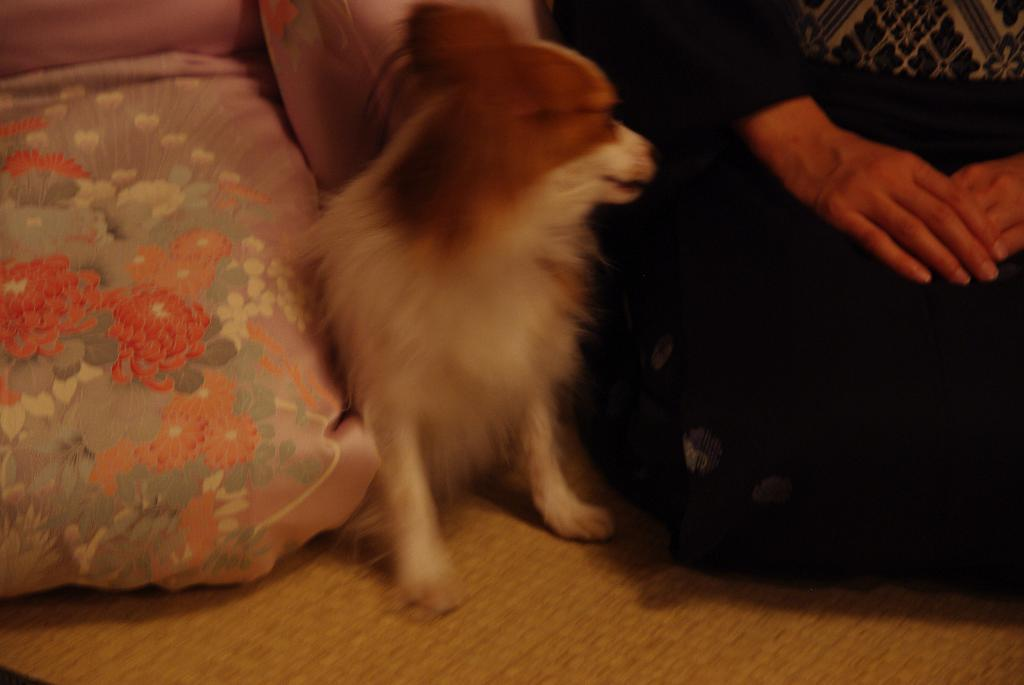What type of animal is in the image? There is a dog in the image. What colors can be seen on the dog? The dog is white and brown in color. What is located on the right side of the image? There are human hands on the right side of the image. How many apples are on the sidewalk in the image? There are no apples or sidewalks present in the image; it features a dog and human hands. 